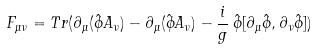Convert formula to latex. <formula><loc_0><loc_0><loc_500><loc_500>F _ { \mu \nu } = T r ( \partial _ { \mu } ( \hat { \phi } A _ { \nu } ) - \partial _ { \mu } ( \hat { \phi } A _ { \nu } ) - \frac { i } { g } \, \hat { \phi } [ \partial _ { \mu } \hat { \phi } , \partial _ { \nu } \hat { \phi } ] )</formula> 